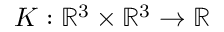Convert formula to latex. <formula><loc_0><loc_0><loc_500><loc_500>K \colon \mathbb { R } ^ { 3 } \times \mathbb { R } ^ { 3 } \rightarrow \mathbb { R }</formula> 